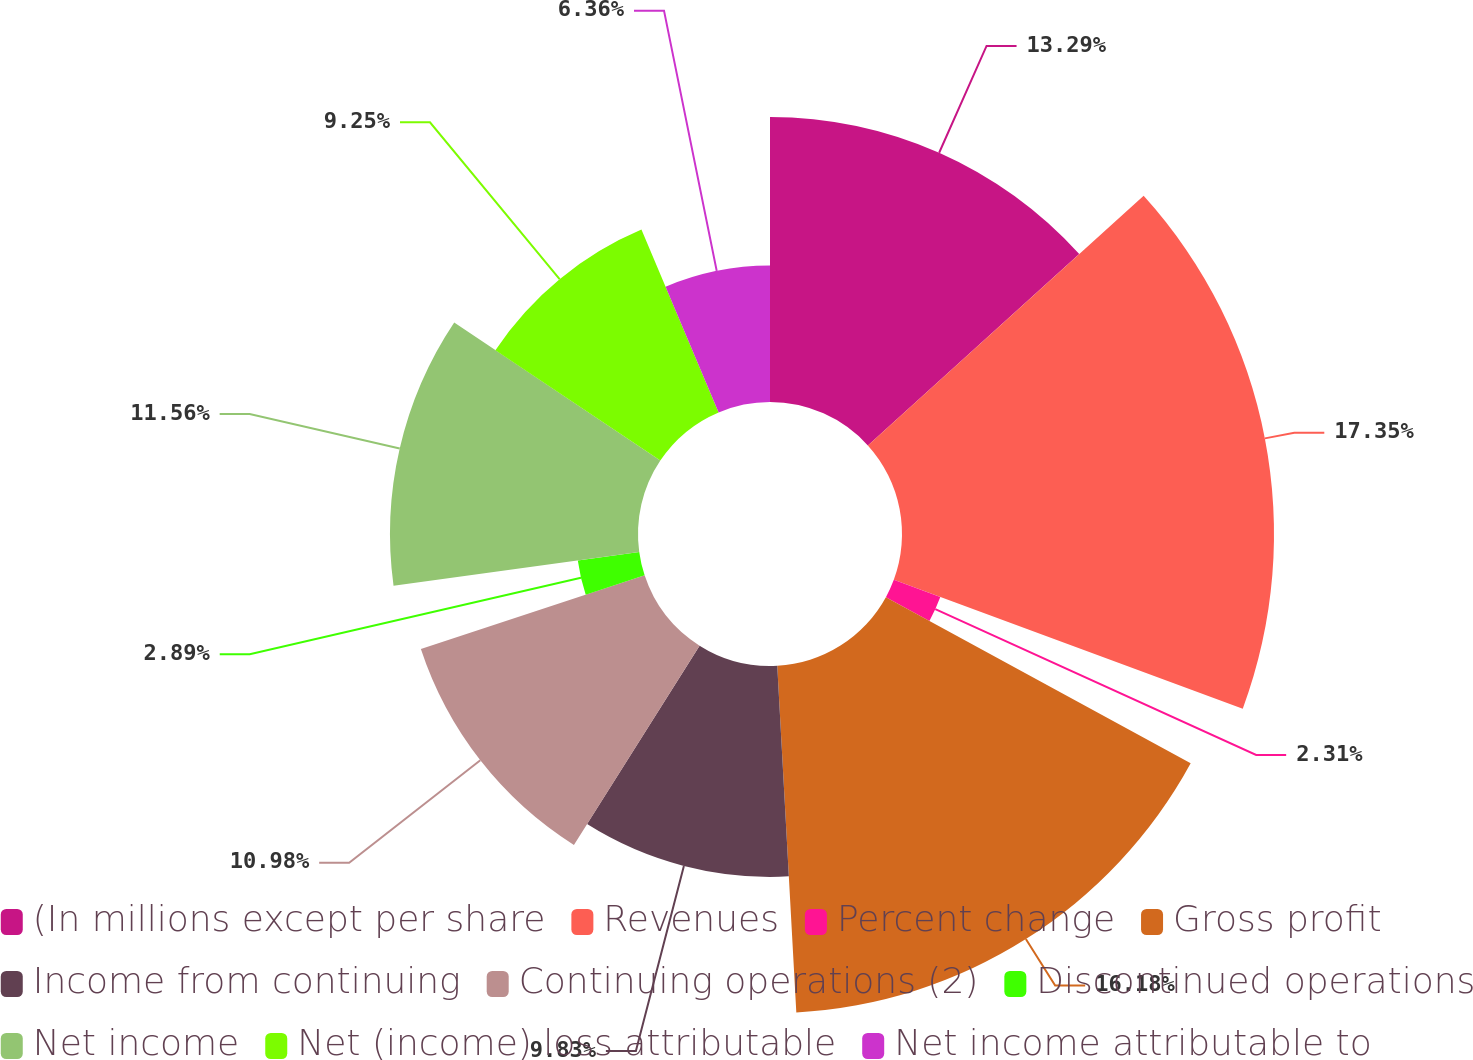Convert chart to OTSL. <chart><loc_0><loc_0><loc_500><loc_500><pie_chart><fcel>(In millions except per share<fcel>Revenues<fcel>Percent change<fcel>Gross profit<fcel>Income from continuing<fcel>Continuing operations (2)<fcel>Discontinued operations<fcel>Net income<fcel>Net (income) loss attributable<fcel>Net income attributable to<nl><fcel>13.29%<fcel>17.34%<fcel>2.31%<fcel>16.18%<fcel>9.83%<fcel>10.98%<fcel>2.89%<fcel>11.56%<fcel>9.25%<fcel>6.36%<nl></chart> 